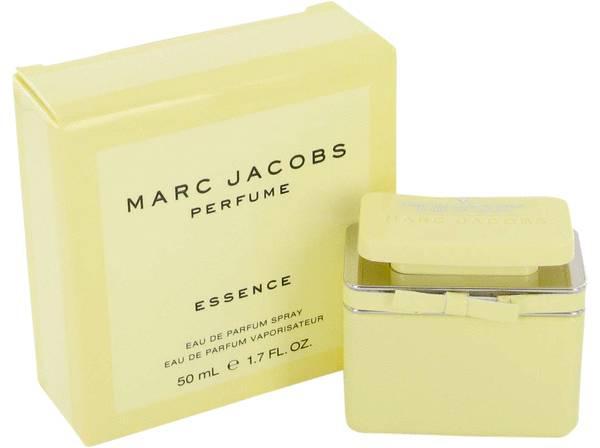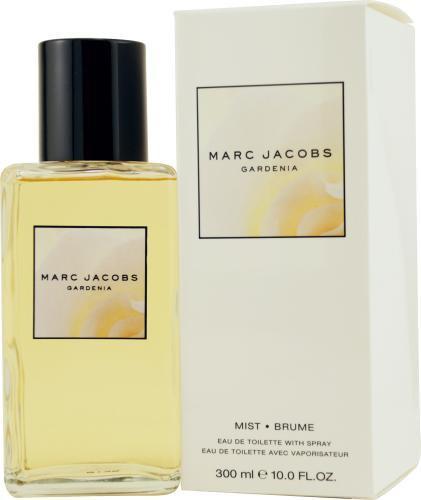The first image is the image on the left, the second image is the image on the right. Assess this claim about the two images: "A perfume bottle in one image is topped with a decorative cap that is covered with plastic daisies.". Correct or not? Answer yes or no. No. 